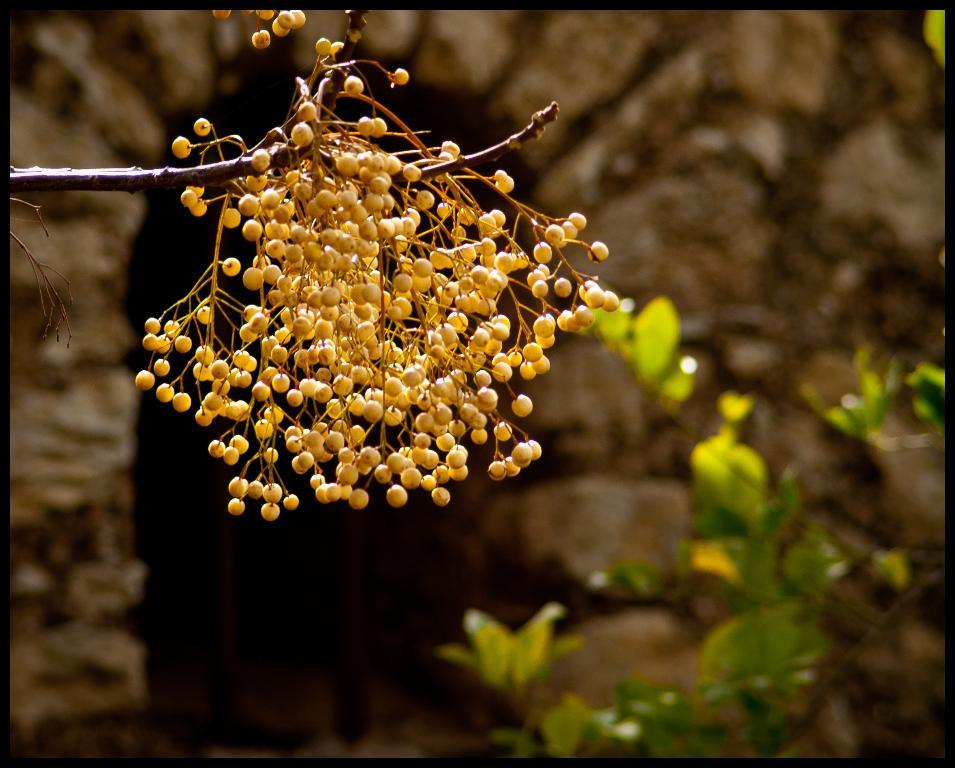What type of plant can be seen in the image? There is a tree in the image. What is hanging from the branches of the tree? Fruits are present on the branches of the tree. What structure is visible in the background of the image? There is a wall visible in the image. What type of egg is being used to make the selection of fruits in the image? There is no egg present in the image, and the fruits are hanging from the branches of the tree, not being selected. 